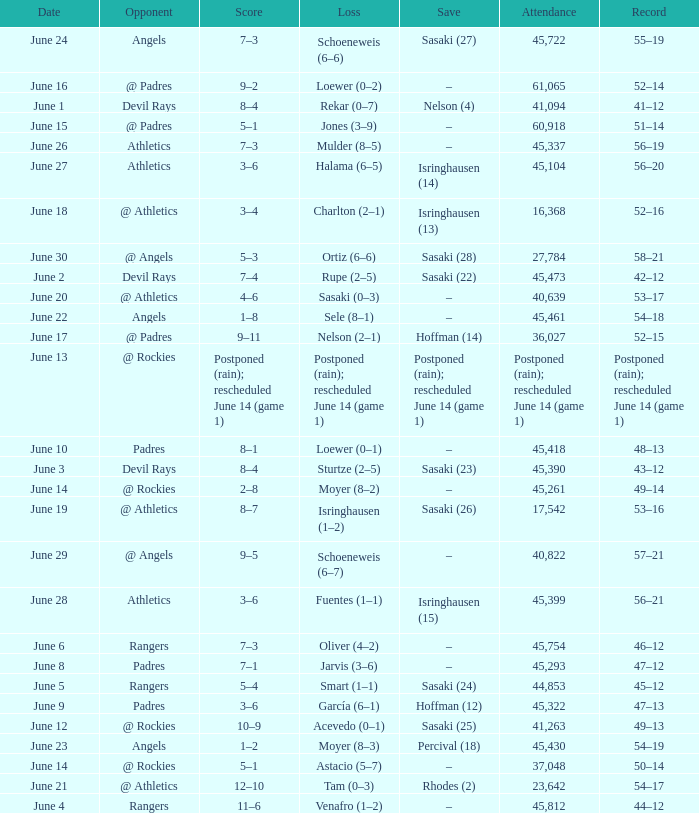What was the date of the Mariners game when they had a record of 53–17? June 20. 